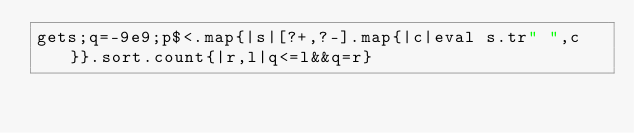<code> <loc_0><loc_0><loc_500><loc_500><_Ruby_>gets;q=-9e9;p$<.map{|s|[?+,?-].map{|c|eval s.tr" ",c}}.sort.count{|r,l|q<=l&&q=r}</code> 